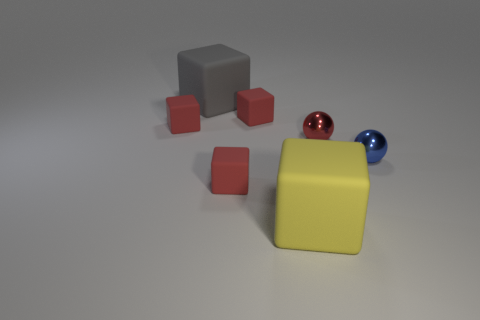Are there an equal number of large gray objects that are behind the big gray matte block and blue objects?
Ensure brevity in your answer.  No. What size is the yellow matte thing that is the same shape as the gray thing?
Ensure brevity in your answer.  Large. There is a big gray thing; is its shape the same as the tiny thing that is in front of the blue shiny object?
Your answer should be very brief. Yes. There is a red rubber object in front of the small metal object that is behind the blue metal ball; what size is it?
Your answer should be compact. Small. Are there the same number of red rubber objects that are behind the gray matte block and red rubber cubes that are to the right of the tiny blue object?
Give a very brief answer. Yes. The other thing that is the same shape as the red metal object is what color?
Offer a very short reply. Blue. There is a big object that is behind the tiny blue sphere; is it the same shape as the yellow thing?
Make the answer very short. Yes. What is the shape of the red object that is right of the large rubber block to the right of the red rubber thing that is in front of the tiny red metal thing?
Provide a succinct answer. Sphere. What size is the gray rubber thing?
Provide a succinct answer. Large. There is a large block that is made of the same material as the gray object; what is its color?
Offer a very short reply. Yellow. 